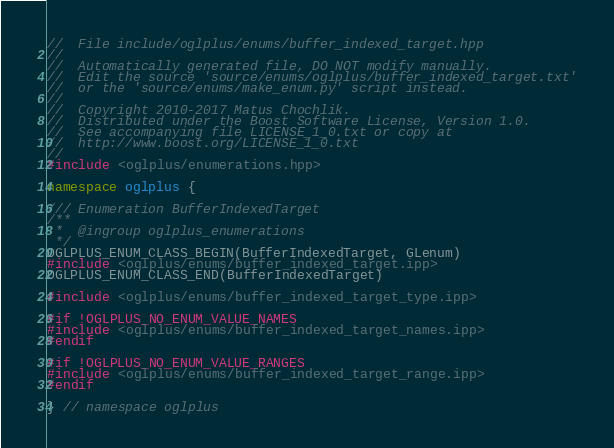Convert code to text. <code><loc_0><loc_0><loc_500><loc_500><_C++_>//  File include/oglplus/enums/buffer_indexed_target.hpp
//
//  Automatically generated file, DO NOT modify manually.
//  Edit the source 'source/enums/oglplus/buffer_indexed_target.txt'
//  or the 'source/enums/make_enum.py' script instead.
//
//  Copyright 2010-2017 Matus Chochlik.
//  Distributed under the Boost Software License, Version 1.0.
//  See accompanying file LICENSE_1_0.txt or copy at
//  http://www.boost.org/LICENSE_1_0.txt
//
#include <oglplus/enumerations.hpp>

namespace oglplus {

/// Enumeration BufferIndexedTarget
/**
 *  @ingroup oglplus_enumerations
 */
OGLPLUS_ENUM_CLASS_BEGIN(BufferIndexedTarget, GLenum)
#include <oglplus/enums/buffer_indexed_target.ipp>
OGLPLUS_ENUM_CLASS_END(BufferIndexedTarget)

#include <oglplus/enums/buffer_indexed_target_type.ipp>

#if !OGLPLUS_NO_ENUM_VALUE_NAMES
#include <oglplus/enums/buffer_indexed_target_names.ipp>
#endif

#if !OGLPLUS_NO_ENUM_VALUE_RANGES
#include <oglplus/enums/buffer_indexed_target_range.ipp>
#endif

} // namespace oglplus
</code> 